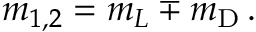Convert formula to latex. <formula><loc_0><loc_0><loc_500><loc_500>m _ { 1 , 2 } = m _ { L } \mp m _ { D } \, .</formula> 